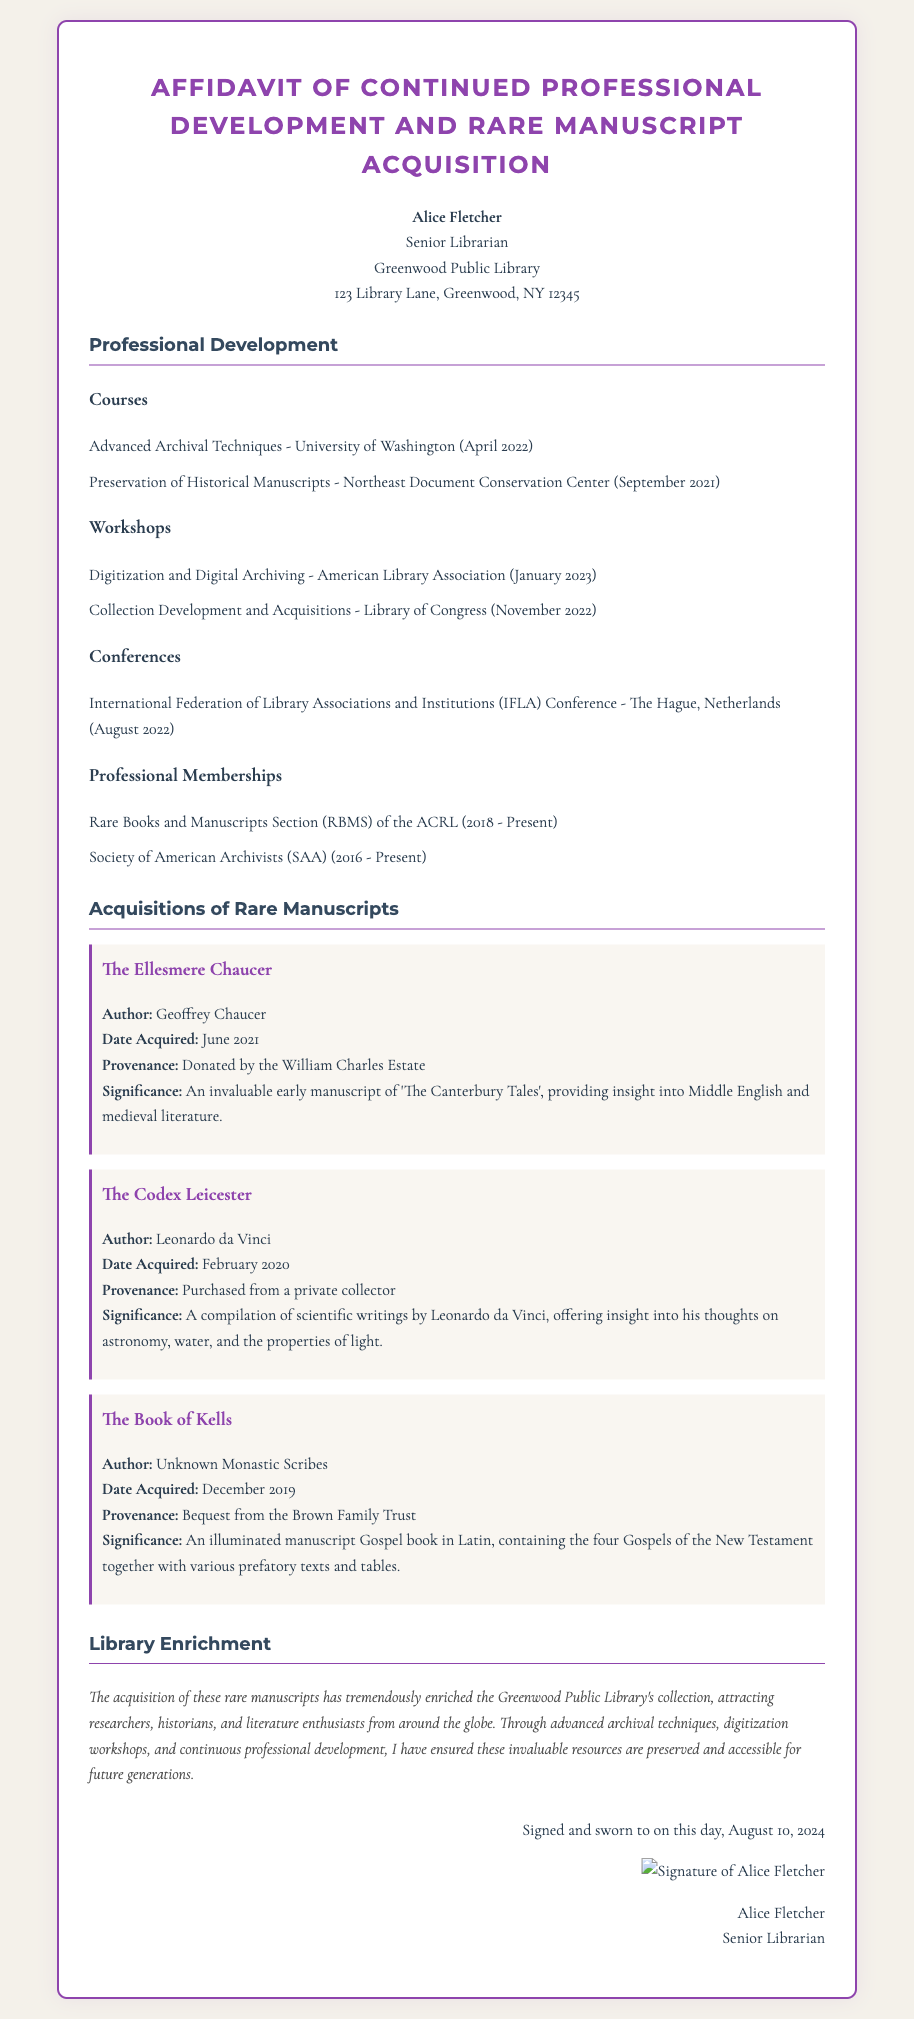What is the name of the person who signed the affidavit? The affidavit states that it was signed by Alice Fletcher.
Answer: Alice Fletcher What is the title of the first course listed under Professional Development? The first course listed is "Advanced Archival Techniques."
Answer: Advanced Archival Techniques When was "The Book of Kells" acquired? The acquisition date for "The Book of Kells" is mentioned as December 2019.
Answer: December 2019 Which organization does the author have a membership with? The document lists membership in the Rare Books and Manuscripts Section of the ACRL.
Answer: Rare Books and Manuscripts Section (RBMS) of the ACRL What is the significance of "The Codex Leicester"? "The Codex Leicester" is significant for its compilation of scientific writings by Leonardo da Vinci.
Answer: Compilation of scientific writings by Leonardo da Vinci What has the acquisition of rare manuscripts achieved for the library? The document states that it has enriched the library's collection and attracted researchers and enthusiasts.
Answer: Enriched the collection and attracted researchers In what year did Alice Fletcher become a member of the Society of American Archivists? The document states her membership began in 2016.
Answer: 2016 What is the date when the affidavit was signed? The affidavit includes the current date when it was signed, which is displayed in the document.
Answer: Displays current date What type of document is this? The document is identified as a signed affidavit.
Answer: Signed affidavit 